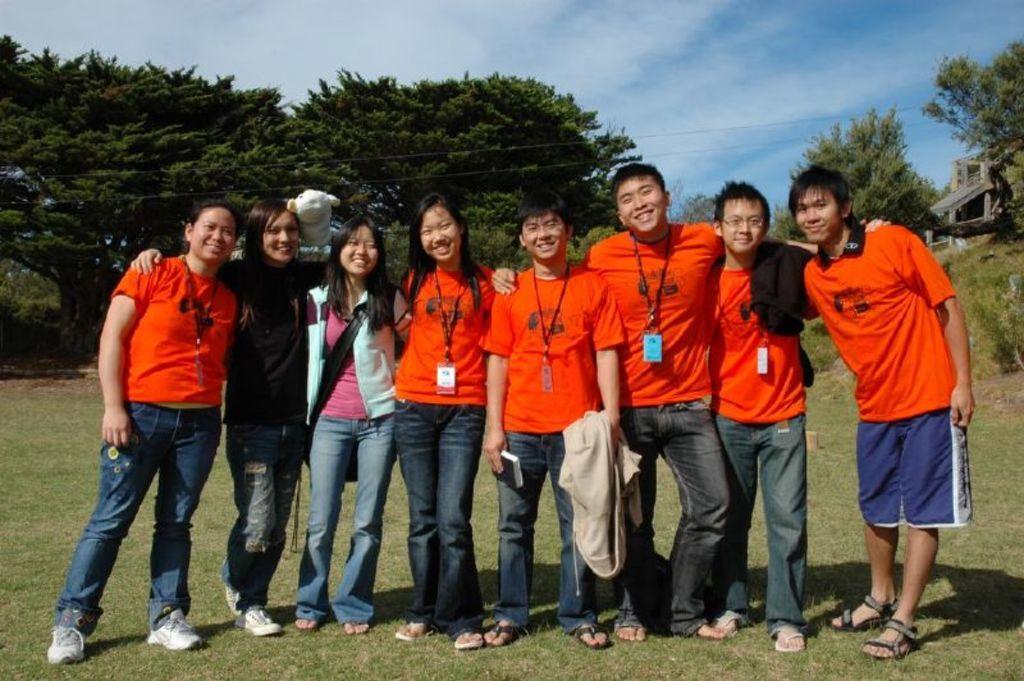Describe this image in one or two sentences. In the front of the image I can see a group of people standing. Among them one person is holding a book and jacket. In the background of the image there are trees, cloudy sky and objects. Land is covered with grass.   